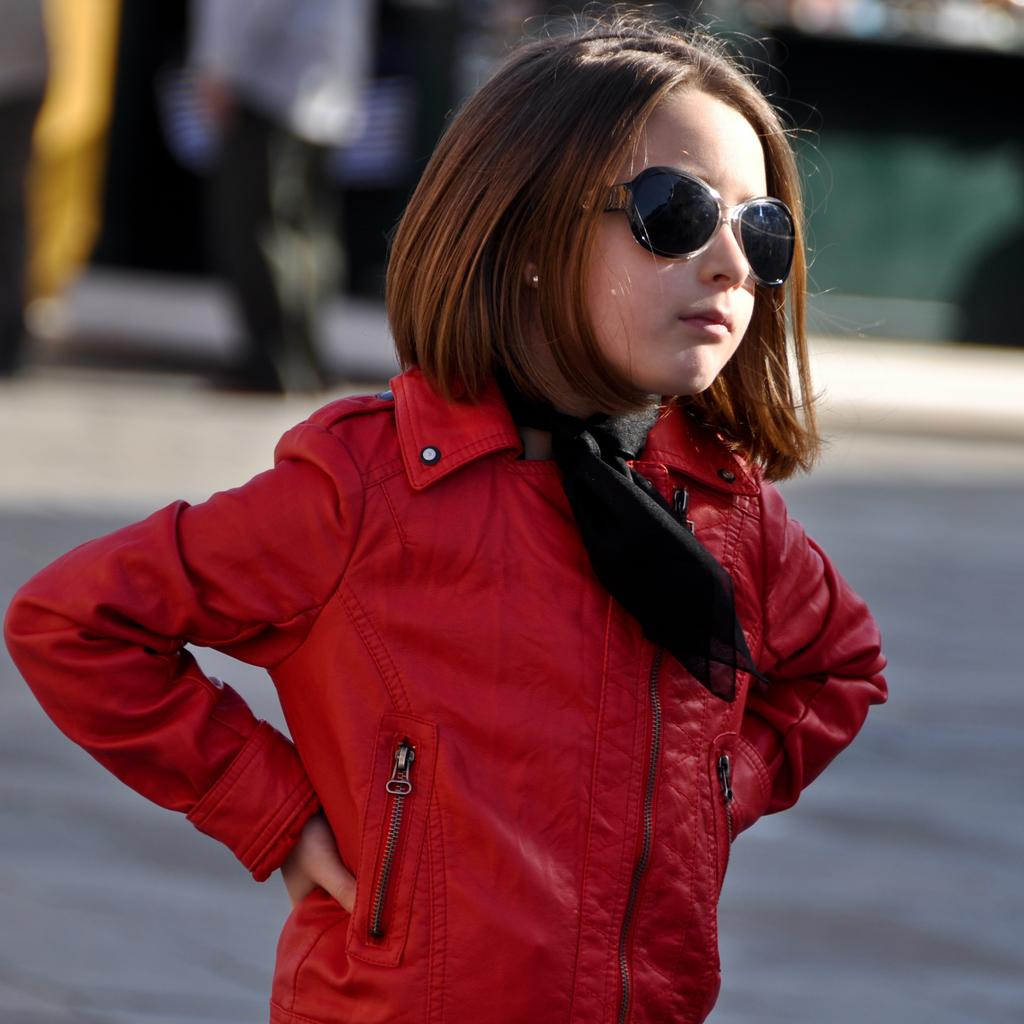Who is the main subject in the image? There is a girl in the image. What is the girl wearing in the image? The girl is wearing glasses in the image. Can you describe the background of the image? The background of the image is blurred. What else can be seen in the background of the image? There are people and a road visible in the background of the image. Can you tell me how many tigers are walking on the trail in the image? There are no tigers or trails present in the image. What method is used to sort the people in the background of the image? There is no sorting method mentioned or visible in the image; the people are simply visible in the background. 